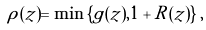<formula> <loc_0><loc_0><loc_500><loc_500>\rho ( z ) = \min \left \{ g ( z ) , 1 + R ( z ) \right \} ,</formula> 